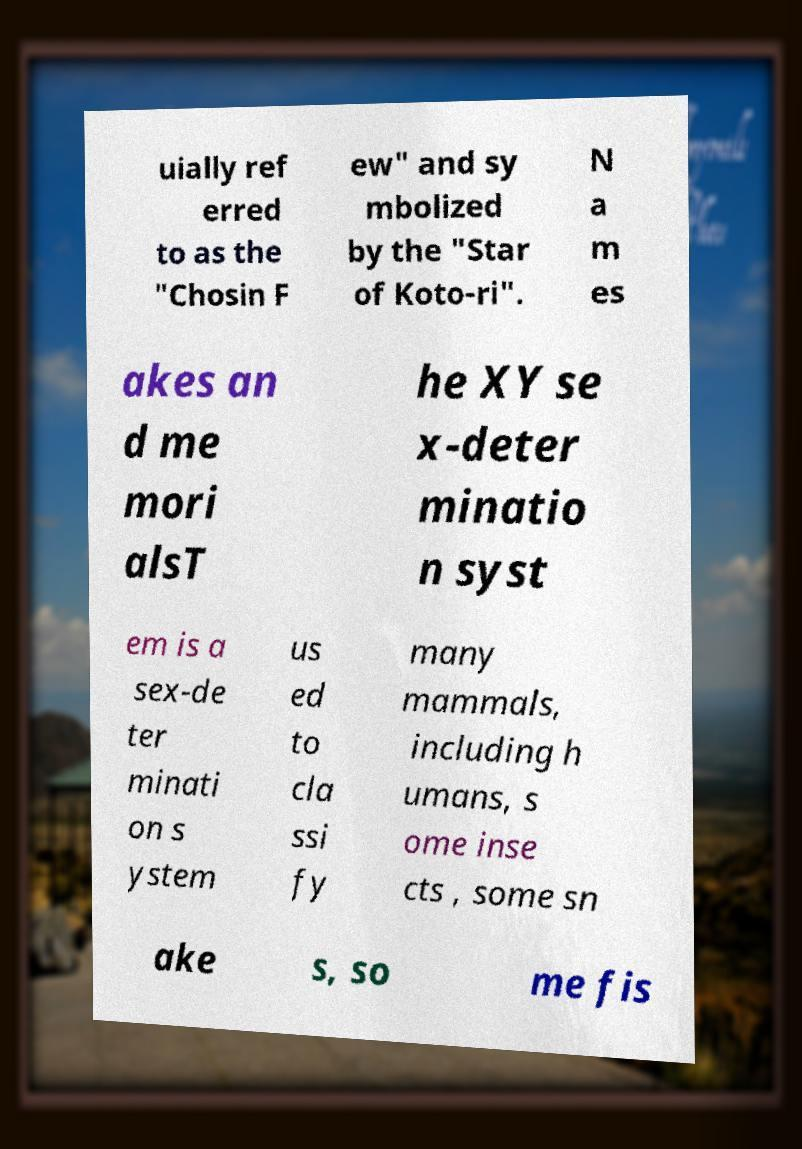There's text embedded in this image that I need extracted. Can you transcribe it verbatim? uially ref erred to as the "Chosin F ew" and sy mbolized by the "Star of Koto-ri". N a m es akes an d me mori alsT he XY se x-deter minatio n syst em is a sex-de ter minati on s ystem us ed to cla ssi fy many mammals, including h umans, s ome inse cts , some sn ake s, so me fis 